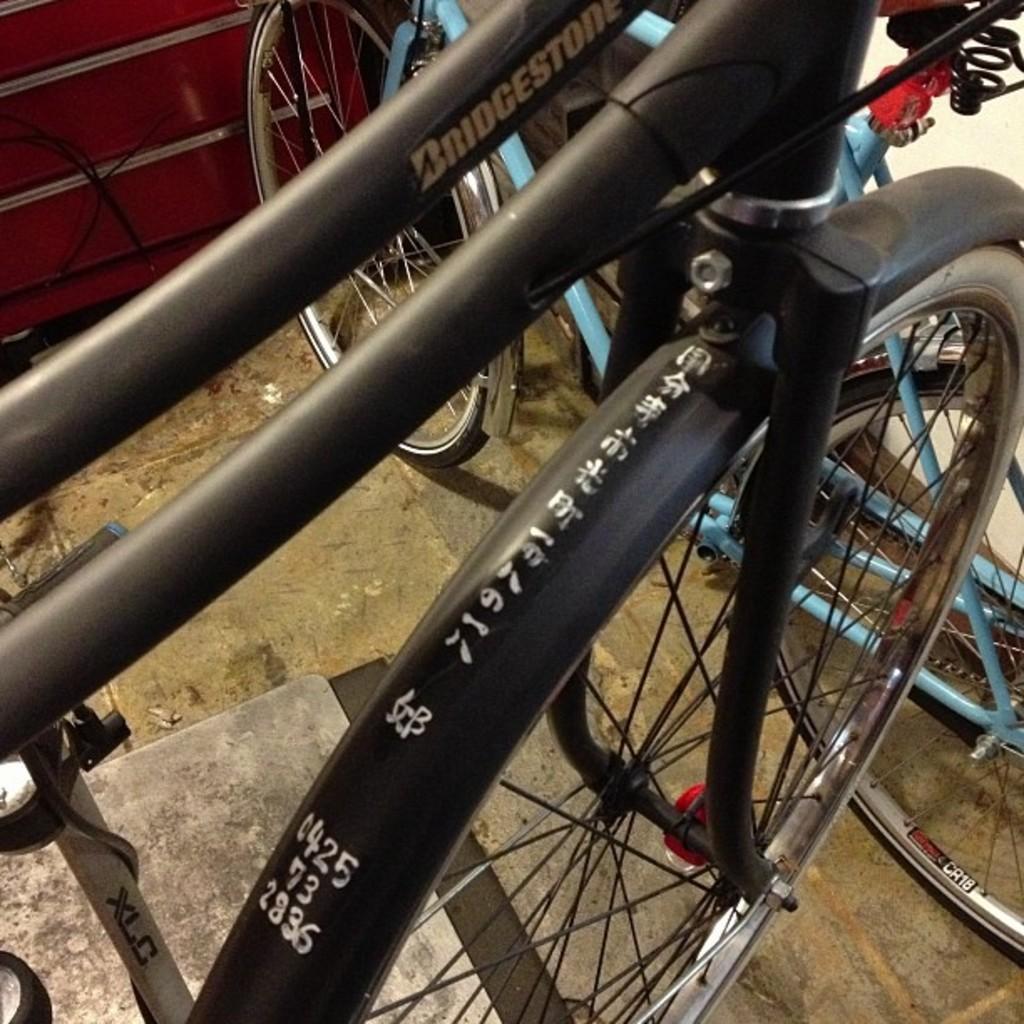Please provide a concise description of this image. Here in this picture we can see bicycles present on the ground over there. 